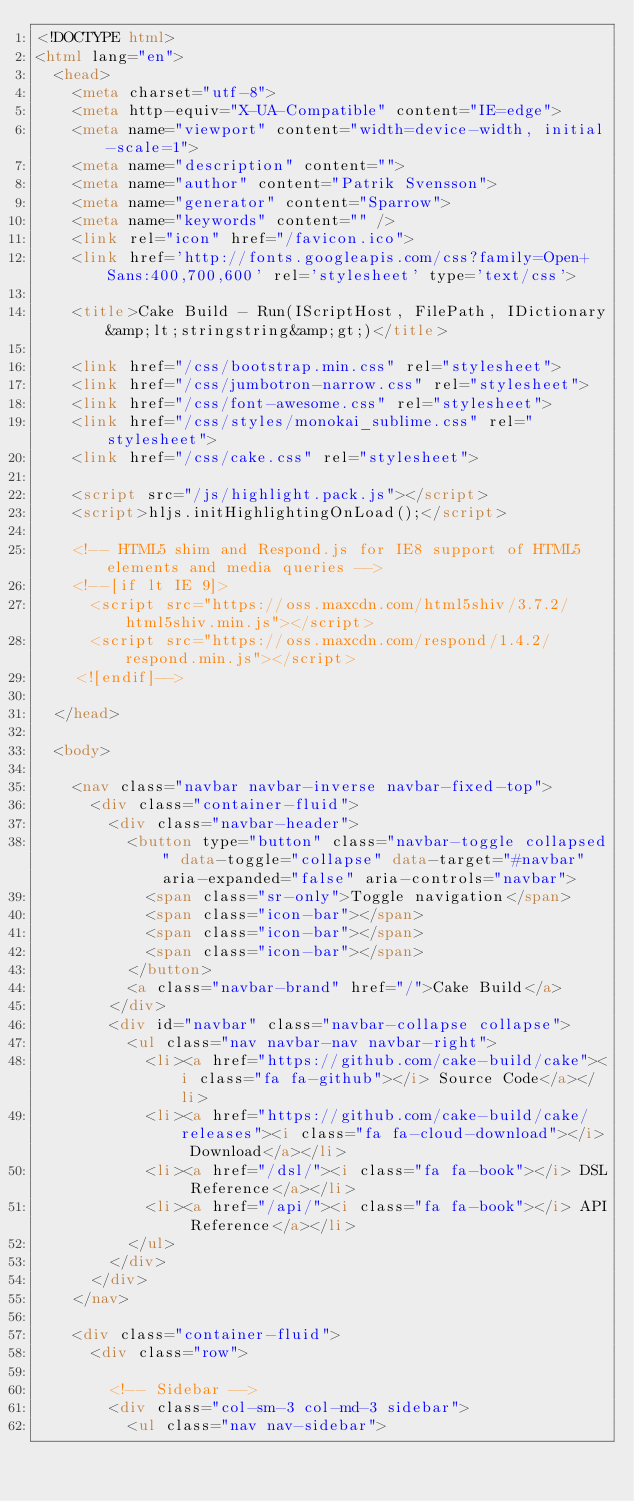Convert code to text. <code><loc_0><loc_0><loc_500><loc_500><_HTML_><!DOCTYPE html>
<html lang="en">
  <head>
    <meta charset="utf-8">
    <meta http-equiv="X-UA-Compatible" content="IE=edge">
    <meta name="viewport" content="width=device-width, initial-scale=1">
    <meta name="description" content="">
    <meta name="author" content="Patrik Svensson">
    <meta name="generator" content="Sparrow">
    <meta name="keywords" content="" />
    <link rel="icon" href="/favicon.ico">
    <link href='http://fonts.googleapis.com/css?family=Open+Sans:400,700,600' rel='stylesheet' type='text/css'>

    <title>Cake Build - Run(IScriptHost, FilePath, IDictionary&amp;lt;stringstring&amp;gt;)</title>

    <link href="/css/bootstrap.min.css" rel="stylesheet">
    <link href="/css/jumbotron-narrow.css" rel="stylesheet">
    <link href="/css/font-awesome.css" rel="stylesheet">
    <link href="/css/styles/monokai_sublime.css" rel="stylesheet">
    <link href="/css/cake.css" rel="stylesheet">

    <script src="/js/highlight.pack.js"></script>    
    <script>hljs.initHighlightingOnLoad();</script>

    <!-- HTML5 shim and Respond.js for IE8 support of HTML5 elements and media queries -->
    <!--[if lt IE 9]>
      <script src="https://oss.maxcdn.com/html5shiv/3.7.2/html5shiv.min.js"></script>
      <script src="https://oss.maxcdn.com/respond/1.4.2/respond.min.js"></script>
    <![endif]-->

  </head>

  <body>

    <nav class="navbar navbar-inverse navbar-fixed-top">
      <div class="container-fluid">
        <div class="navbar-header">
          <button type="button" class="navbar-toggle collapsed" data-toggle="collapse" data-target="#navbar" aria-expanded="false" aria-controls="navbar">
            <span class="sr-only">Toggle navigation</span>
            <span class="icon-bar"></span>
            <span class="icon-bar"></span>
            <span class="icon-bar"></span>
          </button>
          <a class="navbar-brand" href="/">Cake Build</a>
        </div>
        <div id="navbar" class="navbar-collapse collapse">
          <ul class="nav navbar-nav navbar-right">
            <li><a href="https://github.com/cake-build/cake"><i class="fa fa-github"></i> Source Code</a></li>
            <li><a href="https://github.com/cake-build/cake/releases"><i class="fa fa-cloud-download"></i> Download</a></li>
            <li><a href="/dsl/"><i class="fa fa-book"></i> DSL Reference</a></li>
            <li><a href="/api/"><i class="fa fa-book"></i> API Reference</a></li>
          </ul>
        </div>        
      </div>
    </nav>

    <div class="container-fluid">
      <div class="row">

        <!-- Sidebar -->
        <div class="col-sm-3 col-md-3 sidebar">   
          <ul class="nav nav-sidebar"></code> 